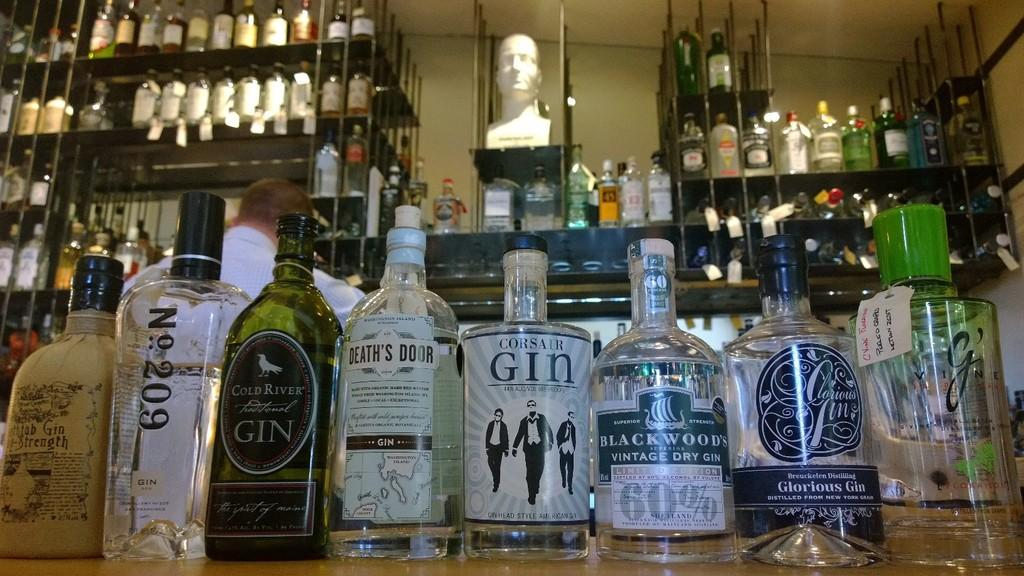<image>
Share a concise interpretation of the image provided. bottle of Gin on a bar counter in front of other liquor bottles 